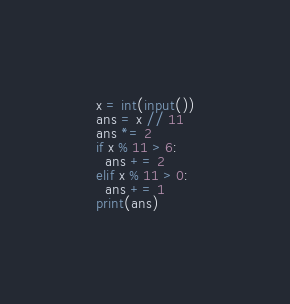<code> <loc_0><loc_0><loc_500><loc_500><_Python_>x = int(input())
ans = x // 11
ans *= 2
if x % 11 > 6:
  ans += 2
elif x % 11 > 0:
  ans += 1
print(ans)</code> 